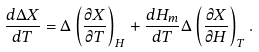<formula> <loc_0><loc_0><loc_500><loc_500>\frac { d \Delta X } { d T } = \Delta \left ( \frac { \partial X } { \partial T } \right ) _ { H } + \frac { d H _ { m } } { d T } \Delta \left ( \frac { \partial X } { \partial H } \right ) _ { T } .</formula> 